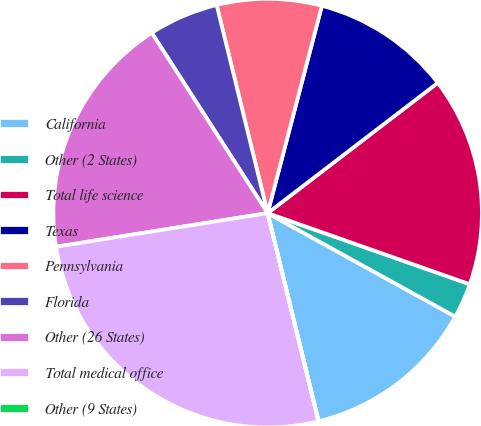Convert chart to OTSL. <chart><loc_0><loc_0><loc_500><loc_500><pie_chart><fcel>California<fcel>Other (2 States)<fcel>Total life science<fcel>Texas<fcel>Pennsylvania<fcel>Florida<fcel>Other (26 States)<fcel>Total medical office<fcel>Other (9 States)<nl><fcel>13.16%<fcel>2.64%<fcel>15.79%<fcel>10.53%<fcel>7.9%<fcel>5.27%<fcel>18.42%<fcel>26.31%<fcel>0.01%<nl></chart> 